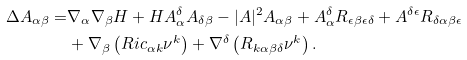<formula> <loc_0><loc_0><loc_500><loc_500>\Delta A _ { \alpha \beta } = & \nabla _ { \alpha } \nabla _ { \beta } H + H A ^ { \delta } _ { \alpha } A _ { \delta \beta } - | A | ^ { 2 } A _ { \alpha \beta } + A ^ { \delta } _ { \alpha } R _ { \epsilon \beta \epsilon \delta } + A ^ { \delta \epsilon } R _ { \delta \alpha \beta \epsilon } \\ & + \nabla _ { \beta } \left ( R i c _ { \alpha k } \nu ^ { k } \right ) + \nabla ^ { \delta } \left ( R _ { k \alpha \beta \delta } \nu ^ { k } \right ) .</formula> 